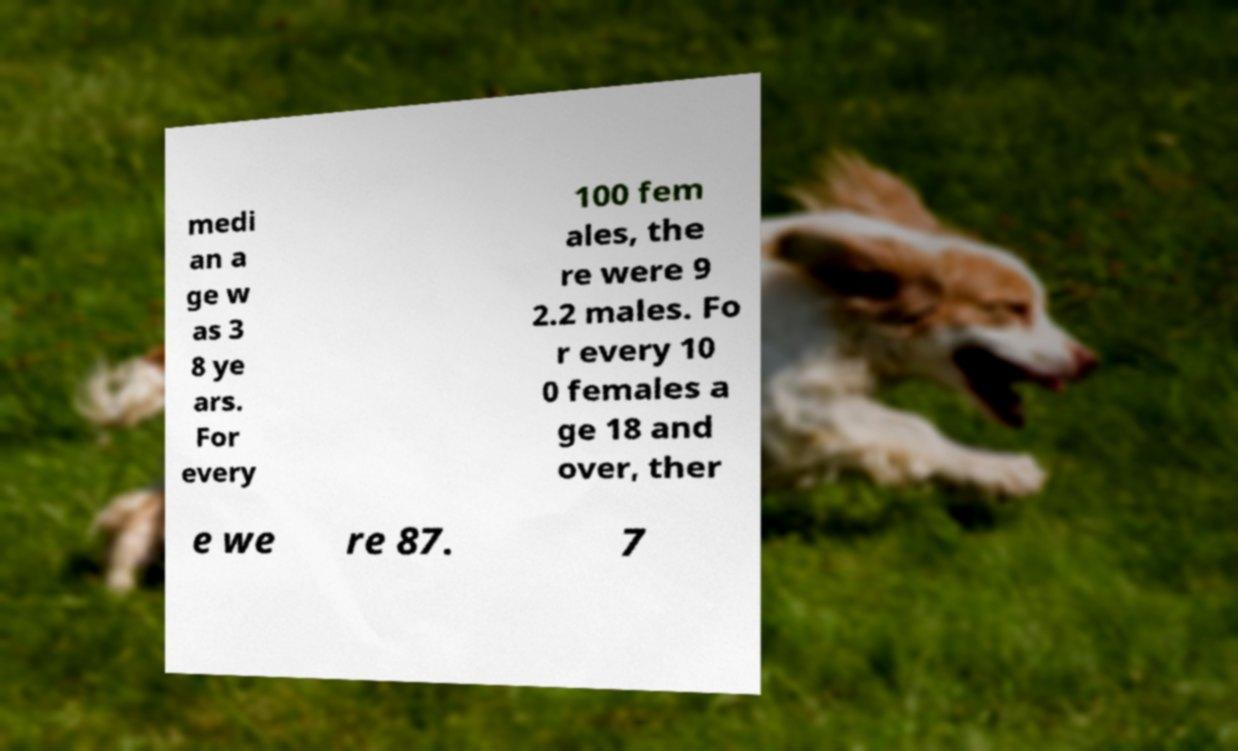Please read and relay the text visible in this image. What does it say? medi an a ge w as 3 8 ye ars. For every 100 fem ales, the re were 9 2.2 males. Fo r every 10 0 females a ge 18 and over, ther e we re 87. 7 